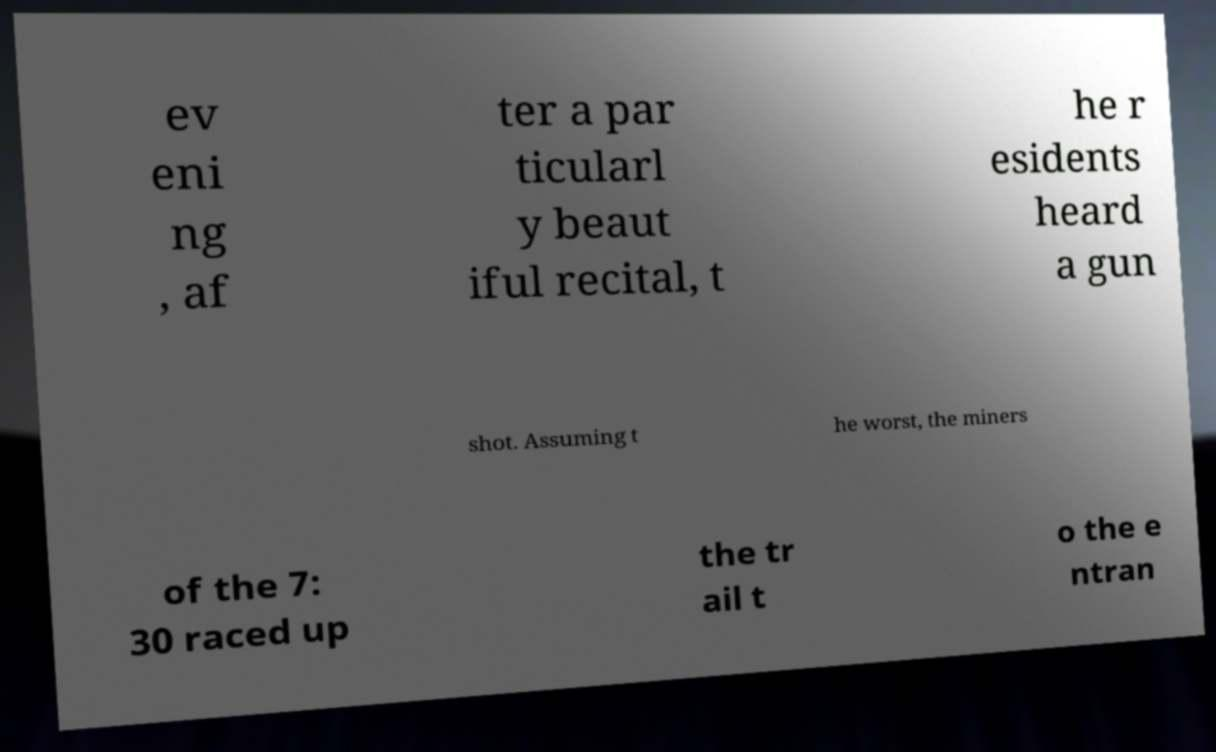For documentation purposes, I need the text within this image transcribed. Could you provide that? ev eni ng , af ter a par ticularl y beaut iful recital, t he r esidents heard a gun shot. Assuming t he worst, the miners of the 7: 30 raced up the tr ail t o the e ntran 